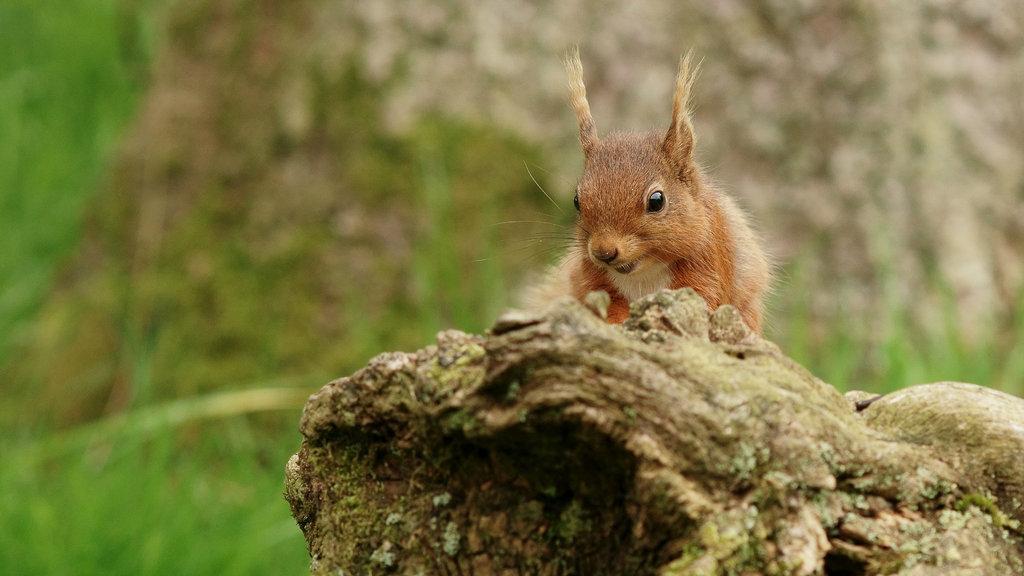Please provide a concise description of this image. In this picture we can see a fox squirrel here, at the bottom there is grass, we can see blurry background. 